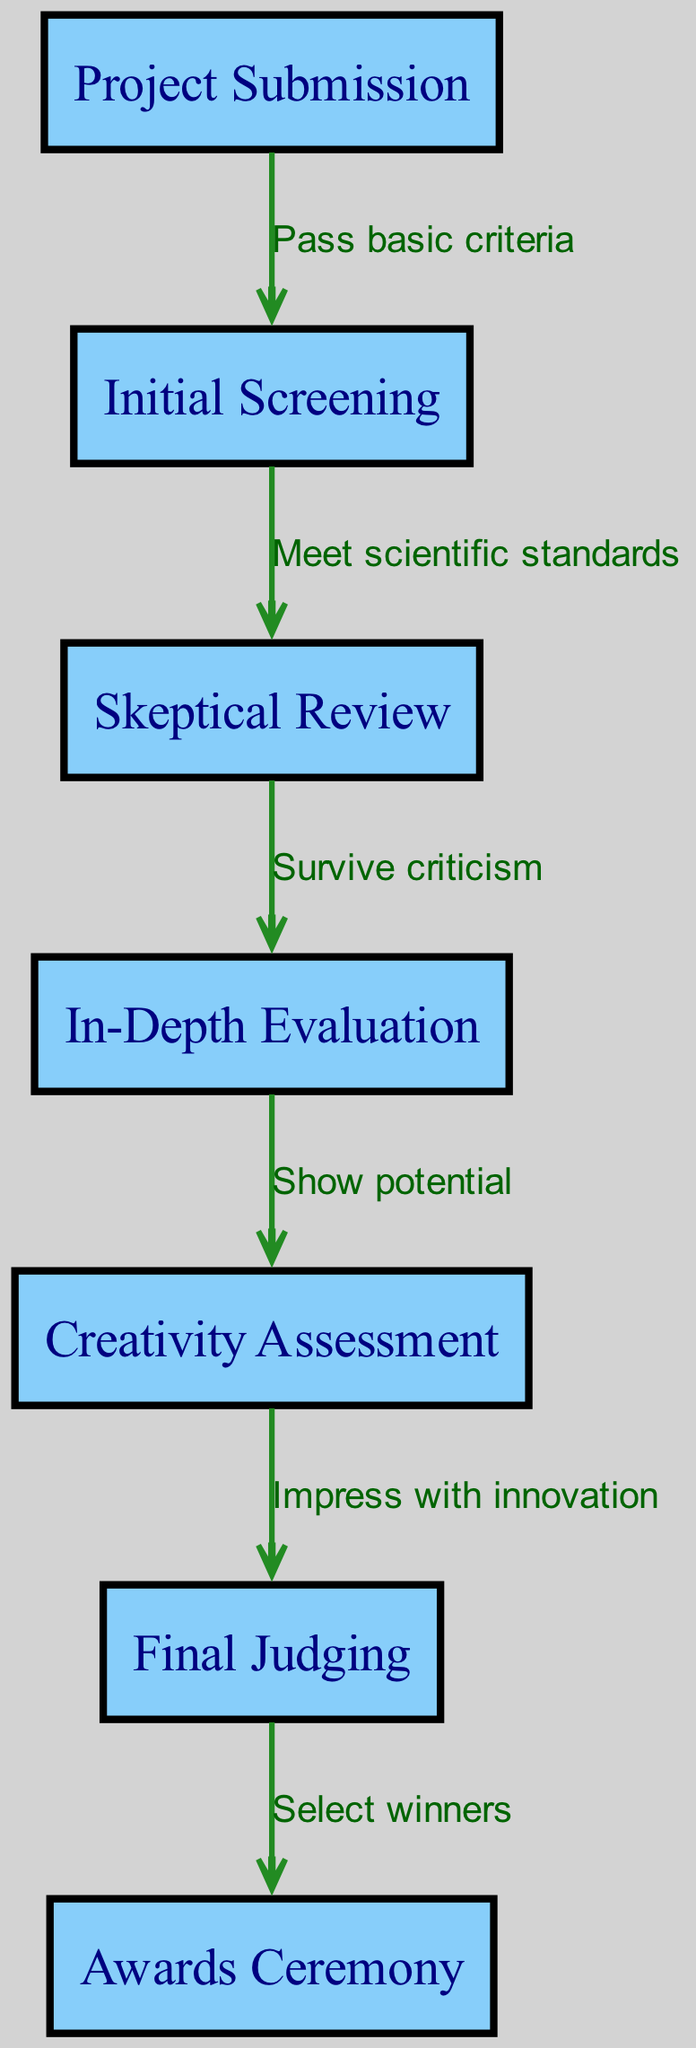What is the total number of nodes in the diagram? The diagram lists the nodes: Project Submission, Initial Screening, Skeptical Review, In-Depth Evaluation, Creativity Assessment, Final Judging, and Awards Ceremony. Counting these gives a total of 7 nodes.
Answer: 7 What is the final step of the project evaluation process? The directed graph shows that the last node is Awards Ceremony, indicating that it is the final step after all evaluations and judging.
Answer: Awards Ceremony What label connects Initial Screening and Skeptical Review? The edge between Initial Screening and Skeptical Review is labeled "Meet scientific standards," which indicates the criteria for progressing to the skeptical review stage.
Answer: Meet scientific standards How many edges are there in the diagram? The diagram shows the connections (edges) between the nodes: from Project Submission to Initial Screening, Initial Screening to Skeptical Review, Skeptical Review to In-Depth Evaluation, In-Depth Evaluation to Creativity Assessment, Creativity Assessment to Final Judging, and Final Judging to Awards Ceremony. Counting these gives a total of 6 edges.
Answer: 6 What must a project do to progress from Skeptical Review to In-Depth Evaluation? The label on the edge leading from Skeptical Review to In-Depth Evaluation states "Survive criticism," which is the requirement for advancing to the deeper evaluation stage.
Answer: Survive criticism What process follows after Creativity Assessment? The directed graph indicates that after the Creativity Assessment, the next step is Final Judging, as shown by the arrow connecting these two nodes.
Answer: Final Judging What is required for a project to advance from In-Depth Evaluation to Creativity Assessment? The edge from In-Depth Evaluation to Creativity Assessment indicates that the project must "Show potential" to move forward in the evaluation process.
Answer: Show potential 